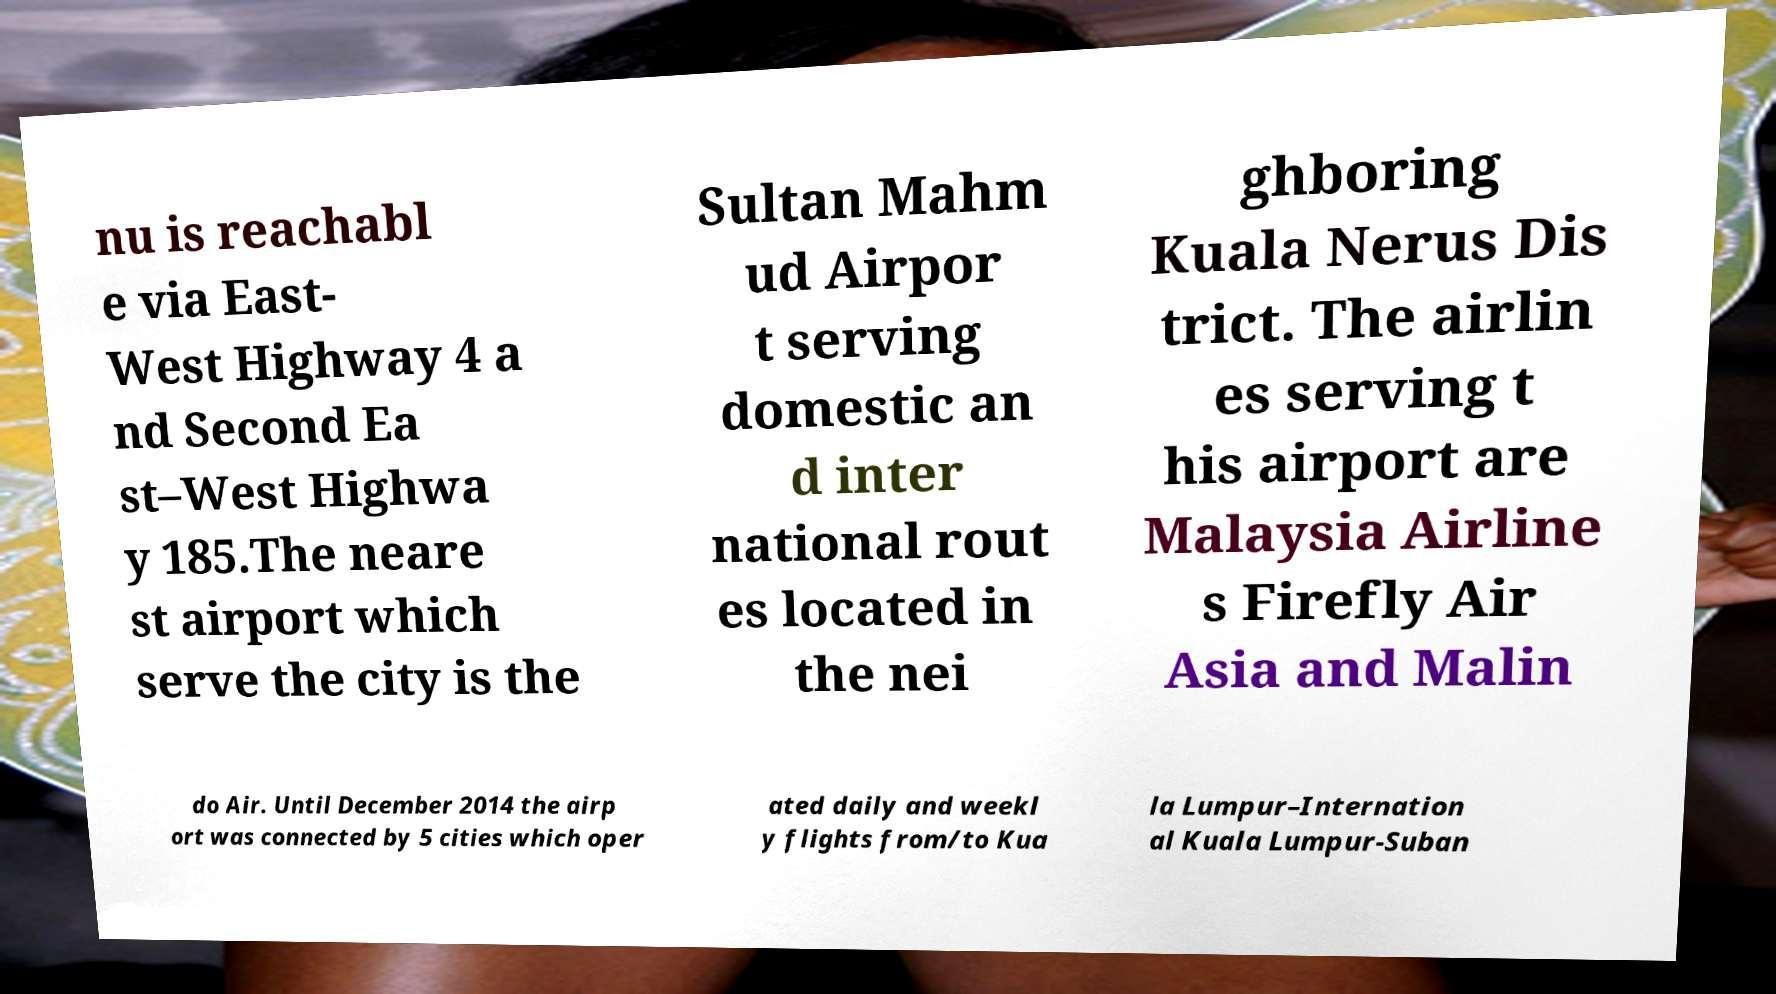I need the written content from this picture converted into text. Can you do that? nu is reachabl e via East- West Highway 4 a nd Second Ea st–West Highwa y 185.The neare st airport which serve the city is the Sultan Mahm ud Airpor t serving domestic an d inter national rout es located in the nei ghboring Kuala Nerus Dis trict. The airlin es serving t his airport are Malaysia Airline s Firefly Air Asia and Malin do Air. Until December 2014 the airp ort was connected by 5 cities which oper ated daily and weekl y flights from/to Kua la Lumpur–Internation al Kuala Lumpur-Suban 